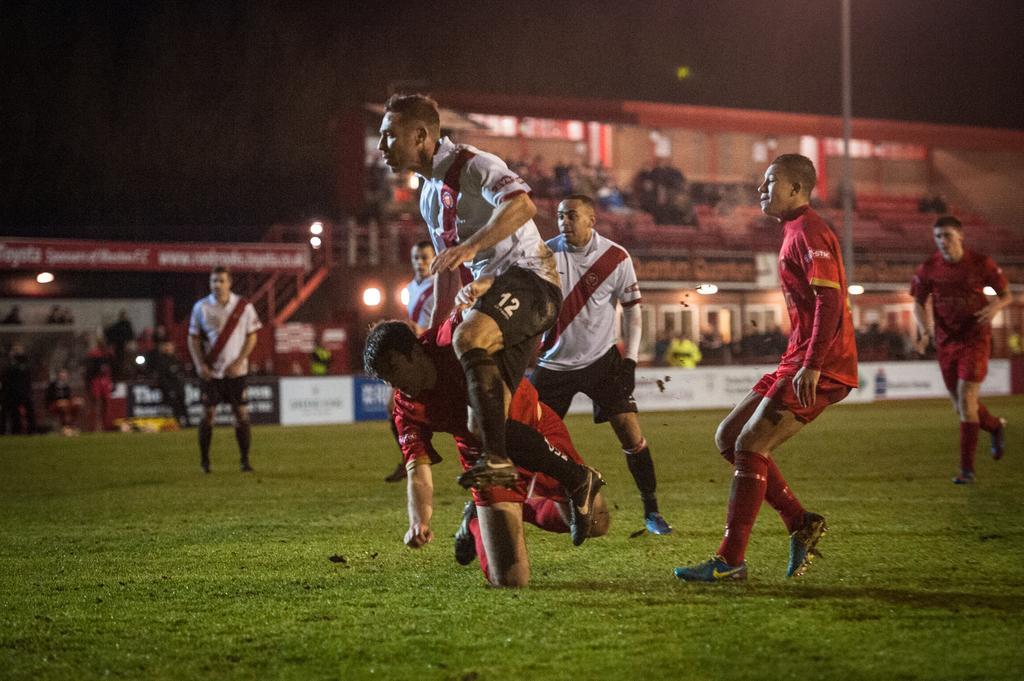Can you describe this image briefly? In this image the foreground there are some people are playing something, and in the background there are group of people who are sitting. And there are some boards, poles, lights, railing, chairs and some other objects. At the bottom there is ground and at the top there is sky. 